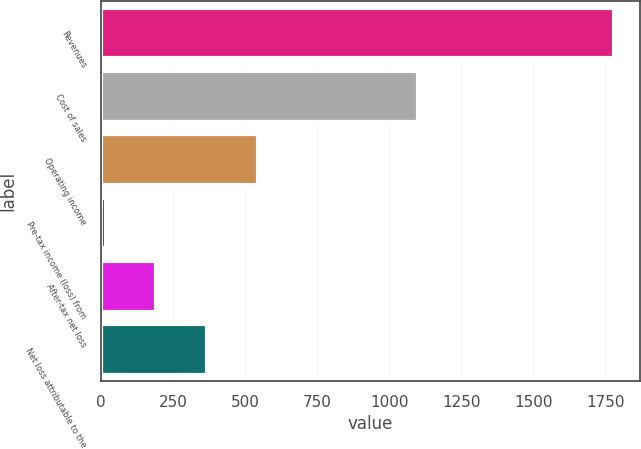<chart> <loc_0><loc_0><loc_500><loc_500><bar_chart><fcel>Revenues<fcel>Cost of sales<fcel>Operating income<fcel>Pre-tax income (loss) from<fcel>After-tax net loss<fcel>Net loss attributable to the<nl><fcel>1780<fcel>1100<fcel>545.2<fcel>16<fcel>192.4<fcel>368.8<nl></chart> 